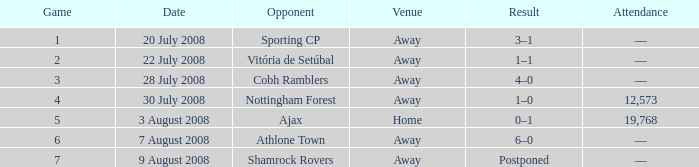What is the total game number with athlone town as the opponent? 1.0. 